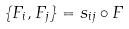Convert formula to latex. <formula><loc_0><loc_0><loc_500><loc_500>\{ F _ { i } , F _ { j } \} = s _ { i j } \circ F</formula> 